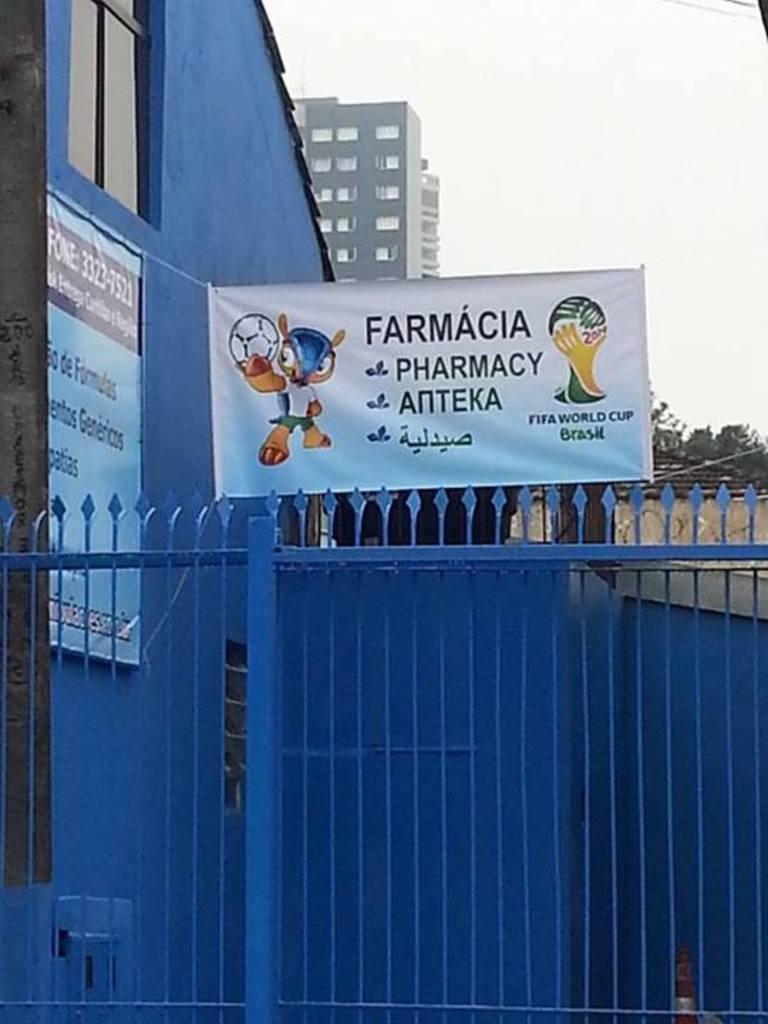<image>
Relay a brief, clear account of the picture shown. A sign by a blue building with a blue fence says Farmacia, Pharmacy, Anteka. 